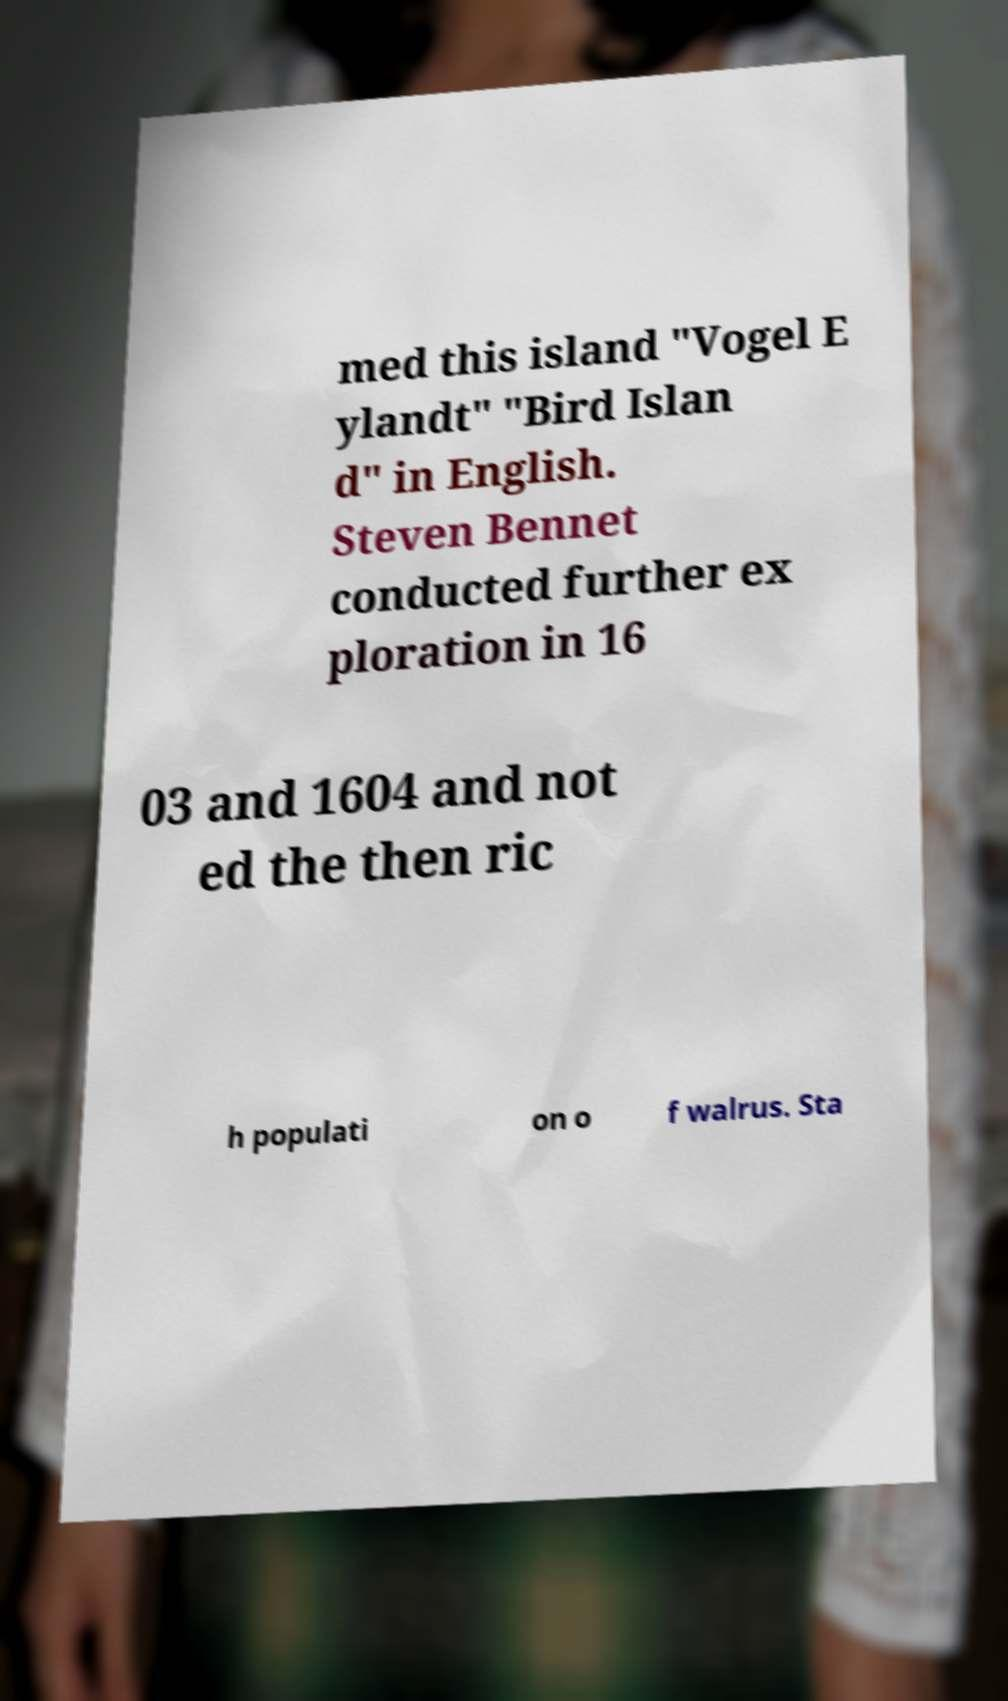Please read and relay the text visible in this image. What does it say? med this island "Vogel E ylandt" "Bird Islan d" in English. Steven Bennet conducted further ex ploration in 16 03 and 1604 and not ed the then ric h populati on o f walrus. Sta 